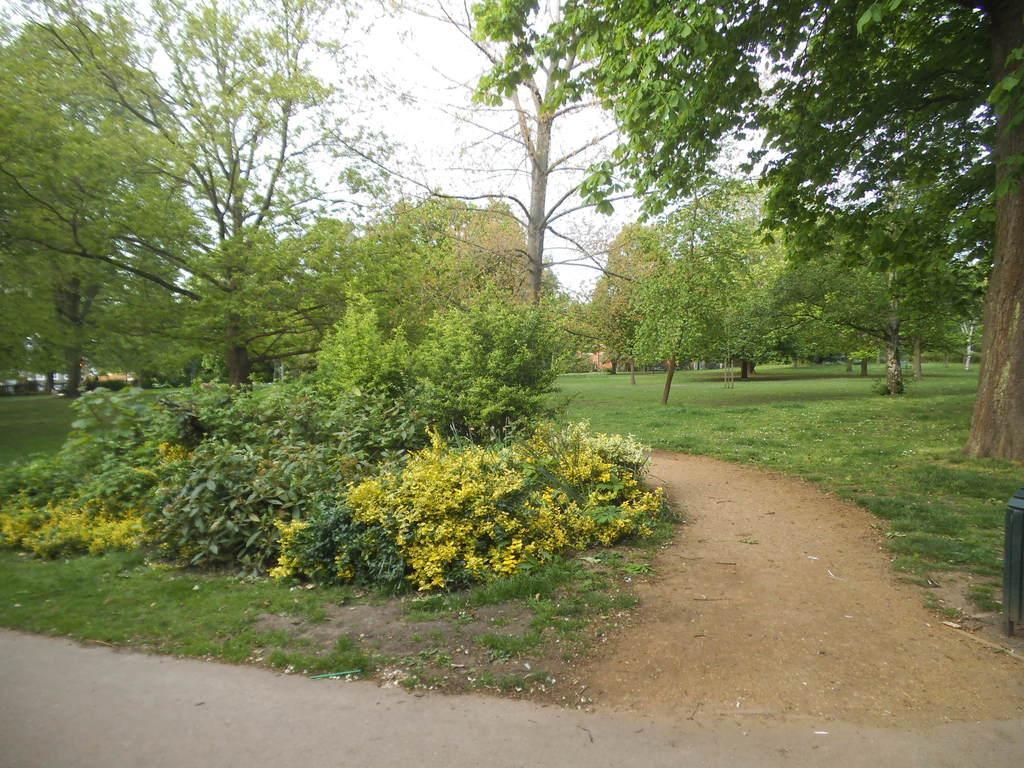In one or two sentences, can you explain what this image depicts? In this image I can see there is a road. And there are trees and plants. And at the top there is a sky. And at the side there is a box. 